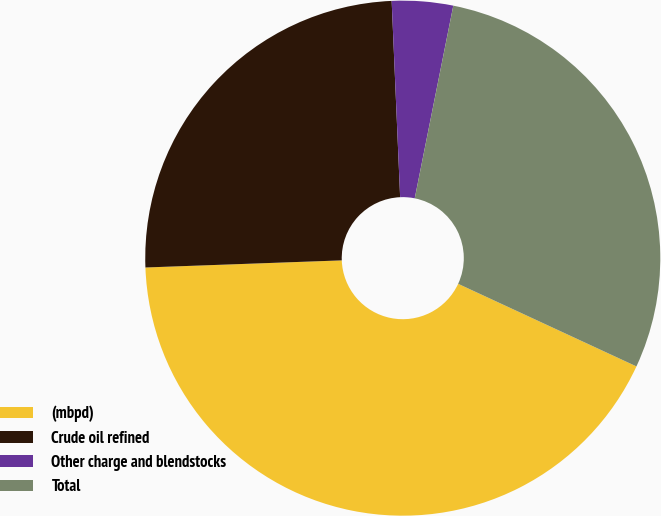<chart> <loc_0><loc_0><loc_500><loc_500><pie_chart><fcel>(mbpd)<fcel>Crude oil refined<fcel>Other charge and blendstocks<fcel>Total<nl><fcel>42.52%<fcel>24.89%<fcel>3.83%<fcel>28.76%<nl></chart> 